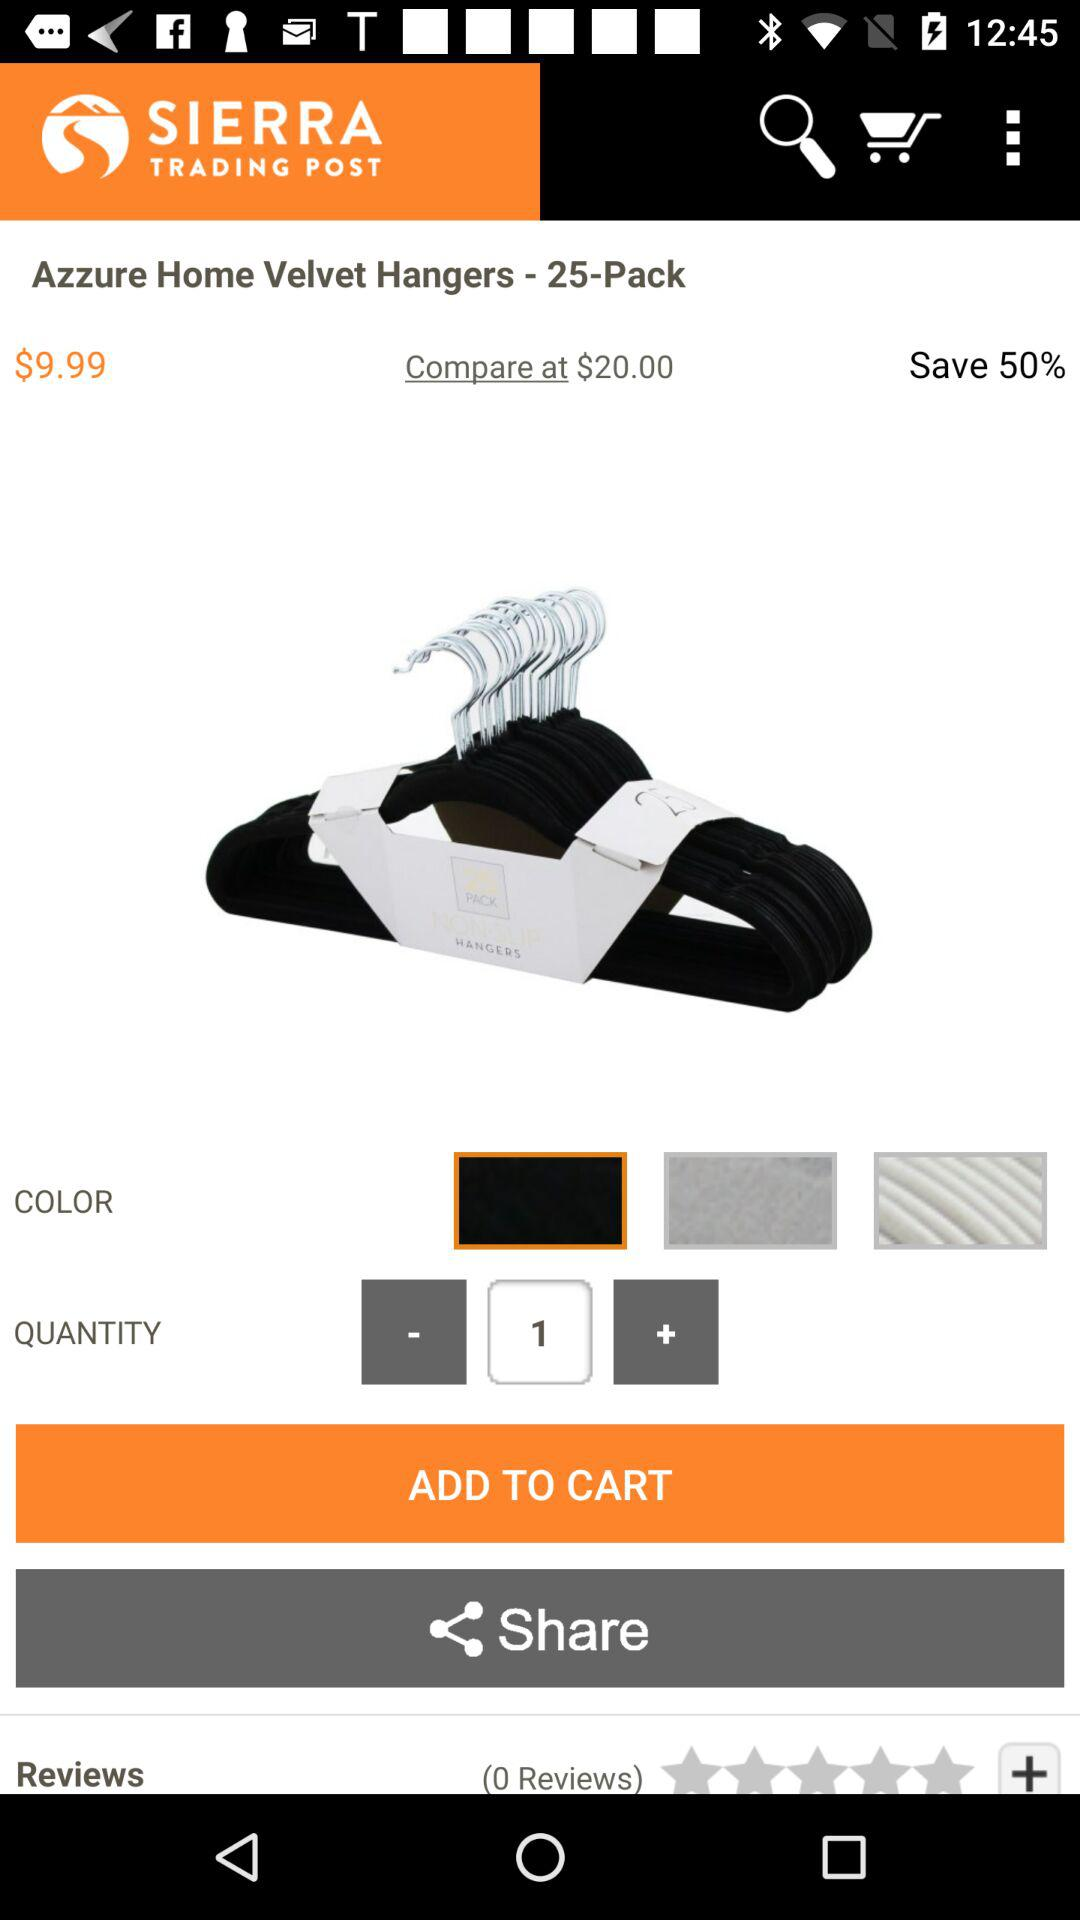How many quantities have you selected? The selected quantity is 1. 